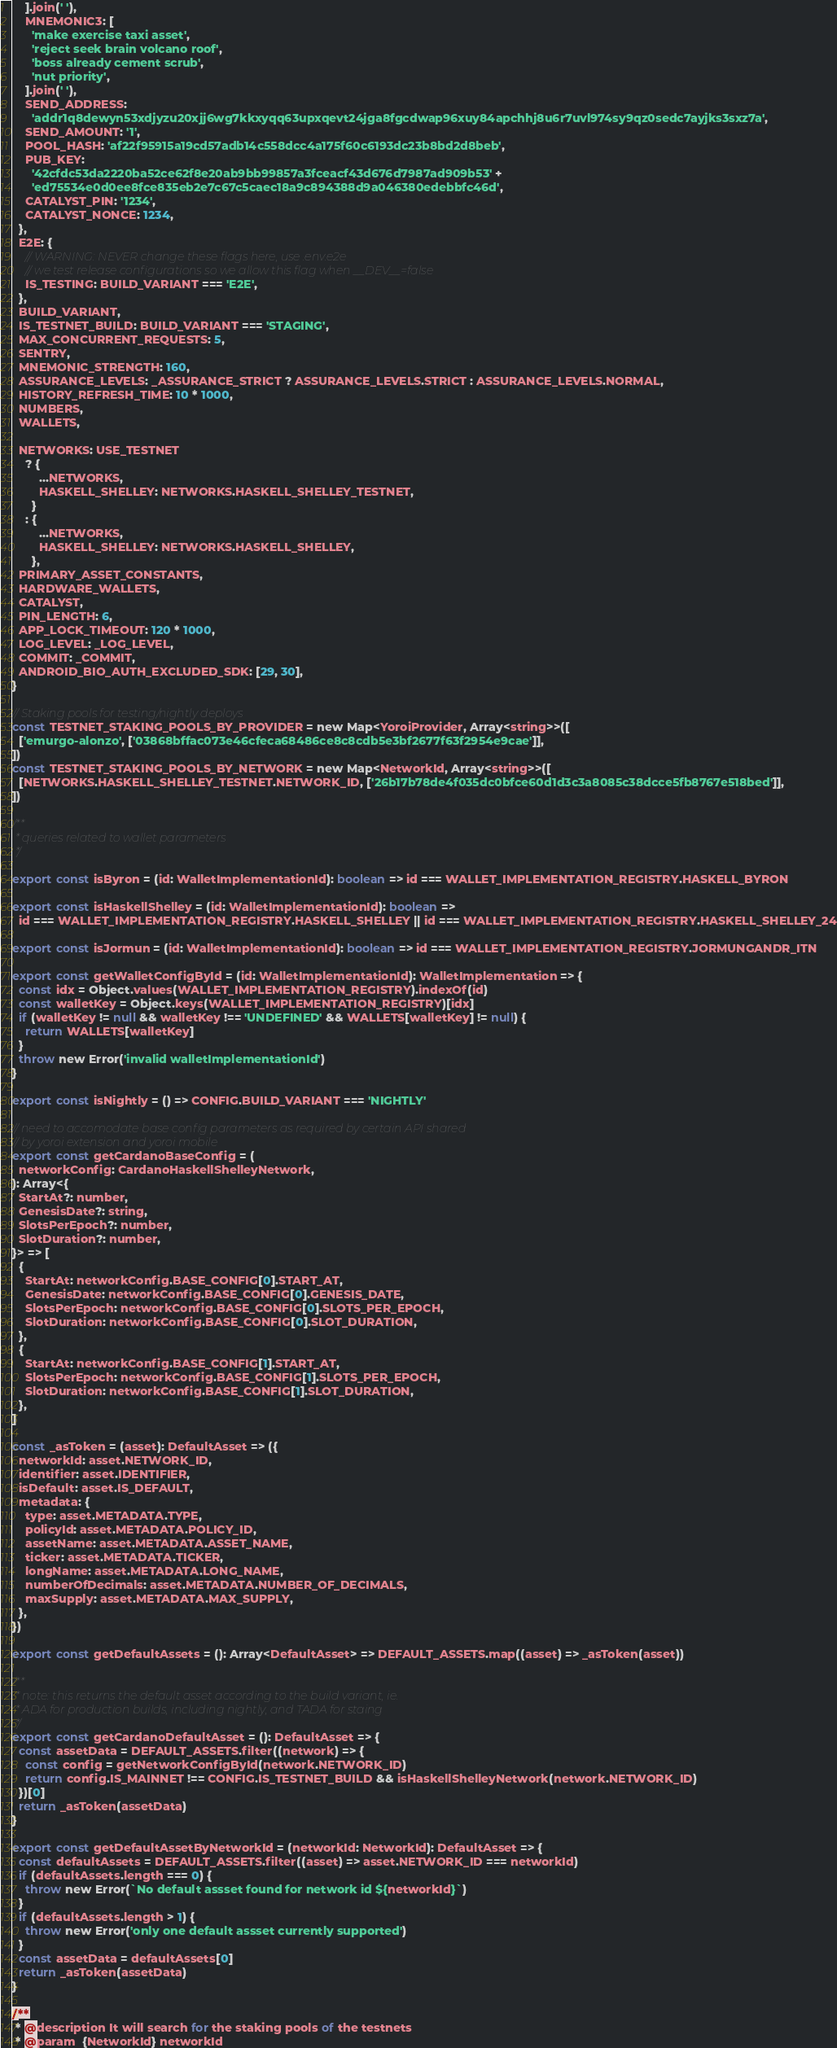<code> <loc_0><loc_0><loc_500><loc_500><_JavaScript_>    ].join(' '),
    MNEMONIC3: [
      'make exercise taxi asset',
      'reject seek brain volcano roof',
      'boss already cement scrub',
      'nut priority',
    ].join(' '),
    SEND_ADDRESS:
      'addr1q8dewyn53xdjyzu20xjj6wg7kkxyqq63upxqevt24jga8fgcdwap96xuy84apchhj8u6r7uvl974sy9qz0sedc7ayjks3sxz7a',
    SEND_AMOUNT: '1',
    POOL_HASH: 'af22f95915a19cd57adb14c558dcc4a175f60c6193dc23b8bd2d8beb',
    PUB_KEY:
      '42cfdc53da2220ba52ce62f8e20ab9bb99857a3fceacf43d676d7987ad909b53' +
      'ed75534e0d0ee8fce835eb2e7c67c5caec18a9c894388d9a046380edebbfc46d',
    CATALYST_PIN: '1234',
    CATALYST_NONCE: 1234,
  },
  E2E: {
    // WARNING: NEVER change these flags here, use .env.e2e
    // we test release configurations so we allow this flag when __DEV__=false
    IS_TESTING: BUILD_VARIANT === 'E2E',
  },
  BUILD_VARIANT,
  IS_TESTNET_BUILD: BUILD_VARIANT === 'STAGING',
  MAX_CONCURRENT_REQUESTS: 5,
  SENTRY,
  MNEMONIC_STRENGTH: 160,
  ASSURANCE_LEVELS: _ASSURANCE_STRICT ? ASSURANCE_LEVELS.STRICT : ASSURANCE_LEVELS.NORMAL,
  HISTORY_REFRESH_TIME: 10 * 1000,
  NUMBERS,
  WALLETS,

  NETWORKS: USE_TESTNET
    ? {
        ...NETWORKS,
        HASKELL_SHELLEY: NETWORKS.HASKELL_SHELLEY_TESTNET,
      }
    : {
        ...NETWORKS,
        HASKELL_SHELLEY: NETWORKS.HASKELL_SHELLEY,
      },
  PRIMARY_ASSET_CONSTANTS,
  HARDWARE_WALLETS,
  CATALYST,
  PIN_LENGTH: 6,
  APP_LOCK_TIMEOUT: 120 * 1000,
  LOG_LEVEL: _LOG_LEVEL,
  COMMIT: _COMMIT,
  ANDROID_BIO_AUTH_EXCLUDED_SDK: [29, 30],
}

// Staking pools for testing/nightly deploys
const TESTNET_STAKING_POOLS_BY_PROVIDER = new Map<YoroiProvider, Array<string>>([
  ['emurgo-alonzo', ['03868bffac073e46cfeca68486ce8c8cdb5e3bf2677f63f2954e9cae']],
])
const TESTNET_STAKING_POOLS_BY_NETWORK = new Map<NetworkId, Array<string>>([
  [NETWORKS.HASKELL_SHELLEY_TESTNET.NETWORK_ID, ['26b17b78de4f035dc0bfce60d1d3c3a8085c38dcce5fb8767e518bed']],
])

/**
 * queries related to wallet parameters
 */

export const isByron = (id: WalletImplementationId): boolean => id === WALLET_IMPLEMENTATION_REGISTRY.HASKELL_BYRON

export const isHaskellShelley = (id: WalletImplementationId): boolean =>
  id === WALLET_IMPLEMENTATION_REGISTRY.HASKELL_SHELLEY || id === WALLET_IMPLEMENTATION_REGISTRY.HASKELL_SHELLEY_24

export const isJormun = (id: WalletImplementationId): boolean => id === WALLET_IMPLEMENTATION_REGISTRY.JORMUNGANDR_ITN

export const getWalletConfigById = (id: WalletImplementationId): WalletImplementation => {
  const idx = Object.values(WALLET_IMPLEMENTATION_REGISTRY).indexOf(id)
  const walletKey = Object.keys(WALLET_IMPLEMENTATION_REGISTRY)[idx]
  if (walletKey != null && walletKey !== 'UNDEFINED' && WALLETS[walletKey] != null) {
    return WALLETS[walletKey]
  }
  throw new Error('invalid walletImplementationId')
}

export const isNightly = () => CONFIG.BUILD_VARIANT === 'NIGHTLY'

// need to accomodate base config parameters as required by certain API shared
// by yoroi extension and yoroi mobile
export const getCardanoBaseConfig = (
  networkConfig: CardanoHaskellShelleyNetwork,
): Array<{
  StartAt?: number,
  GenesisDate?: string,
  SlotsPerEpoch?: number,
  SlotDuration?: number,
}> => [
  {
    StartAt: networkConfig.BASE_CONFIG[0].START_AT,
    GenesisDate: networkConfig.BASE_CONFIG[0].GENESIS_DATE,
    SlotsPerEpoch: networkConfig.BASE_CONFIG[0].SLOTS_PER_EPOCH,
    SlotDuration: networkConfig.BASE_CONFIG[0].SLOT_DURATION,
  },
  {
    StartAt: networkConfig.BASE_CONFIG[1].START_AT,
    SlotsPerEpoch: networkConfig.BASE_CONFIG[1].SLOTS_PER_EPOCH,
    SlotDuration: networkConfig.BASE_CONFIG[1].SLOT_DURATION,
  },
]

const _asToken = (asset): DefaultAsset => ({
  networkId: asset.NETWORK_ID,
  identifier: asset.IDENTIFIER,
  isDefault: asset.IS_DEFAULT,
  metadata: {
    type: asset.METADATA.TYPE,
    policyId: asset.METADATA.POLICY_ID,
    assetName: asset.METADATA.ASSET_NAME,
    ticker: asset.METADATA.TICKER,
    longName: asset.METADATA.LONG_NAME,
    numberOfDecimals: asset.METADATA.NUMBER_OF_DECIMALS,
    maxSupply: asset.METADATA.MAX_SUPPLY,
  },
})

export const getDefaultAssets = (): Array<DefaultAsset> => DEFAULT_ASSETS.map((asset) => _asToken(asset))

/**
 * note: this returns the default asset according to the build variant, ie.
 * ADA for production builds, including nightly, and TADA for staing
 */
export const getCardanoDefaultAsset = (): DefaultAsset => {
  const assetData = DEFAULT_ASSETS.filter((network) => {
    const config = getNetworkConfigById(network.NETWORK_ID)
    return config.IS_MAINNET !== CONFIG.IS_TESTNET_BUILD && isHaskellShelleyNetwork(network.NETWORK_ID)
  })[0]
  return _asToken(assetData)
}

export const getDefaultAssetByNetworkId = (networkId: NetworkId): DefaultAsset => {
  const defaultAssets = DEFAULT_ASSETS.filter((asset) => asset.NETWORK_ID === networkId)
  if (defaultAssets.length === 0) {
    throw new Error(`No default assset found for network id ${networkId}`)
  }
  if (defaultAssets.length > 1) {
    throw new Error('only one default assset currently supported')
  }
  const assetData = defaultAssets[0]
  return _asToken(assetData)
}

/**
 * @description It will search for the staking pools of the testnets
 * @param  {NetworkId} networkId</code> 